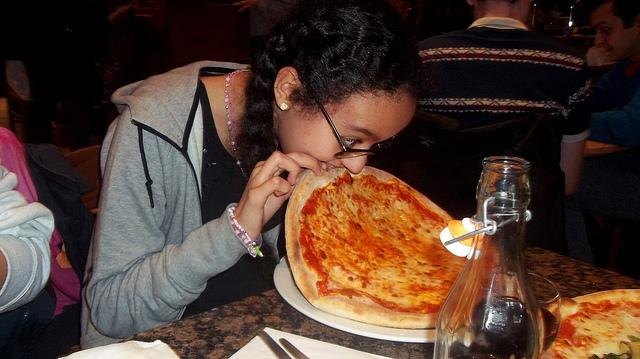What direction are the stripes on the person's shirt going?

Choices:
A) vertical
B) horizontal
C) diagonal
D) intersected horizontal 